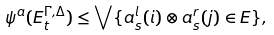Convert formula to latex. <formula><loc_0><loc_0><loc_500><loc_500>\psi ^ { a } ( E ^ { \Gamma , \Delta } _ { t } ) \leq \bigvee \{ a ^ { l } _ { s } ( i ) \otimes a ^ { r } _ { s } ( j ) \in E \} ,</formula> 